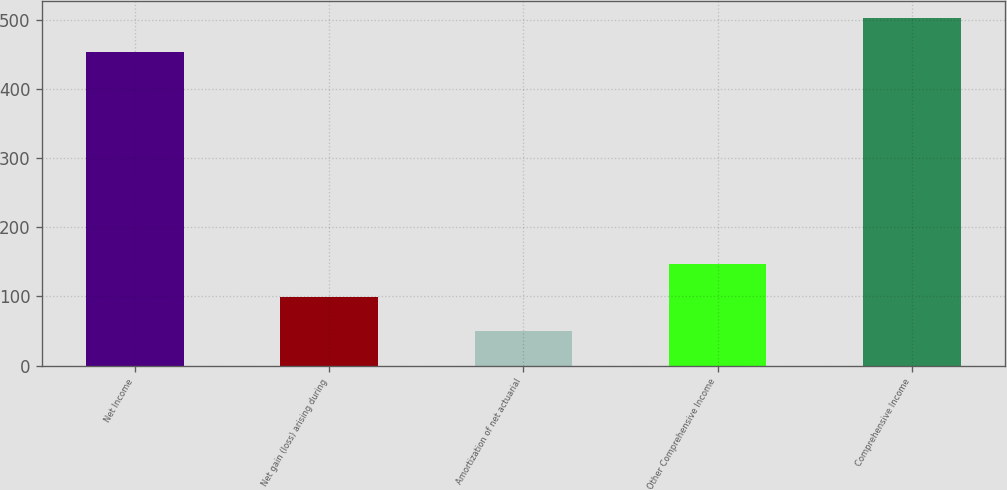<chart> <loc_0><loc_0><loc_500><loc_500><bar_chart><fcel>Net Income<fcel>Net gain (loss) arising during<fcel>Amortization of net actuarial<fcel>Other Comprehensive Income<fcel>Comprehensive Income<nl><fcel>454<fcel>99<fcel>50.5<fcel>147.5<fcel>502.5<nl></chart> 